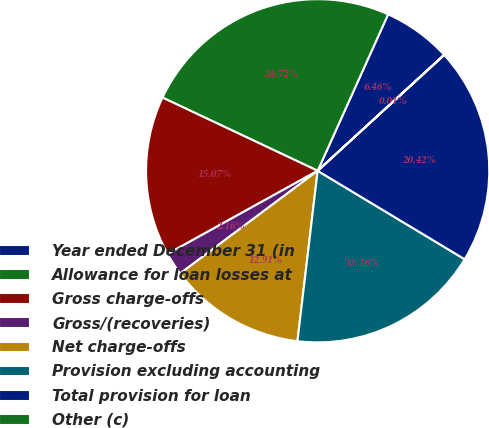Convert chart. <chart><loc_0><loc_0><loc_500><loc_500><pie_chart><fcel>Year ended December 31 (in<fcel>Allowance for loan losses at<fcel>Gross charge-offs<fcel>Gross/(recoveries)<fcel>Net charge-offs<fcel>Provision excluding accounting<fcel>Total provision for loan<fcel>Other (c)<nl><fcel>6.46%<fcel>24.72%<fcel>15.07%<fcel>2.16%<fcel>12.91%<fcel>18.26%<fcel>20.42%<fcel>0.01%<nl></chart> 